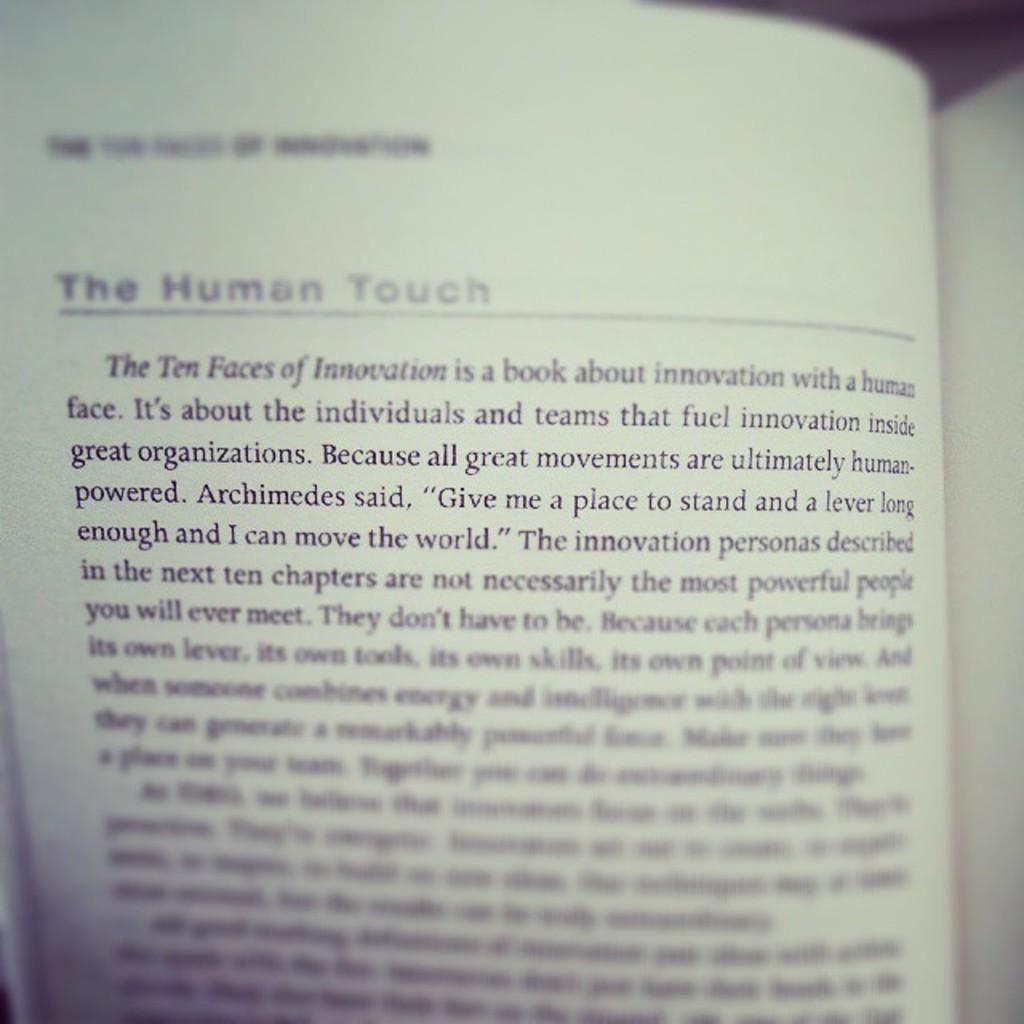<image>
Render a clear and concise summary of the photo. the word touch is on the page of a book 